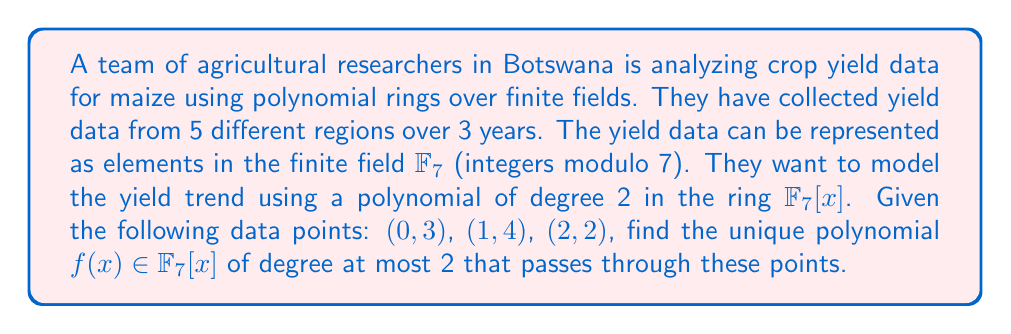Give your solution to this math problem. To find the unique polynomial $f(x) \in \mathbb{F}_7[x]$ of degree at most 2 that passes through the given points, we'll use Lagrange interpolation:

1) The general form of the polynomial is $f(x) = ax^2 + bx + c$, where $a$, $b$, and $c$ are in $\mathbb{F}_7$.

2) Using Lagrange interpolation, we can construct $f(x)$ as:

   $f(x) = y_0L_0(x) + y_1L_1(x) + y_2L_2(x)$

   where $L_i(x)$ are Lagrange basis polynomials.

3) Calculate $L_0(x)$:
   $$L_0(x) = \frac{(x-1)(x-2)}{(0-1)(0-2)} = \frac{x^2-3x+2}{2} = 4x^2 + 5x + 1$$

4) Calculate $L_1(x)$:
   $$L_1(x) = \frac{(x-0)(x-2)}{(1-0)(1-2)} = \frac{x^2-2x}{-1} = 6x^2 + x$$

5) Calculate $L_2(x)$:
   $$L_2(x) = \frac{(x-0)(x-1)}{(2-0)(2-1)} = \frac{x^2-x}{2} = 4x^2 + 4x$$

6) Now, construct $f(x)$:
   $f(x) = 3L_0(x) + 4L_1(x) + 2L_2(x)$
   
   $= 3(4x^2 + 5x + 1) + 4(6x^2 + x) + 2(4x^2 + 4x)$
   
   $= 12x^2 + 15x + 3 + 24x^2 + 4x + 8x^2 + 8x$
   
   $= 44x^2 + 27x + 3$

7) Simplify in $\mathbb{F}_7$:
   $f(x) = 2x^2 + 6x + 3$

8) Verify: 
   $f(0) = 3$, $f(1) = 2 + 6 + 3 = 4$, $f(2) = 8 + 12 + 3 = 23 \equiv 2 \pmod{7}$
Answer: $f(x) = 2x^2 + 6x + 3$ in $\mathbb{F}_7[x]$ 